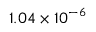<formula> <loc_0><loc_0><loc_500><loc_500>1 . 0 4 \times 1 0 ^ { - 6 }</formula> 